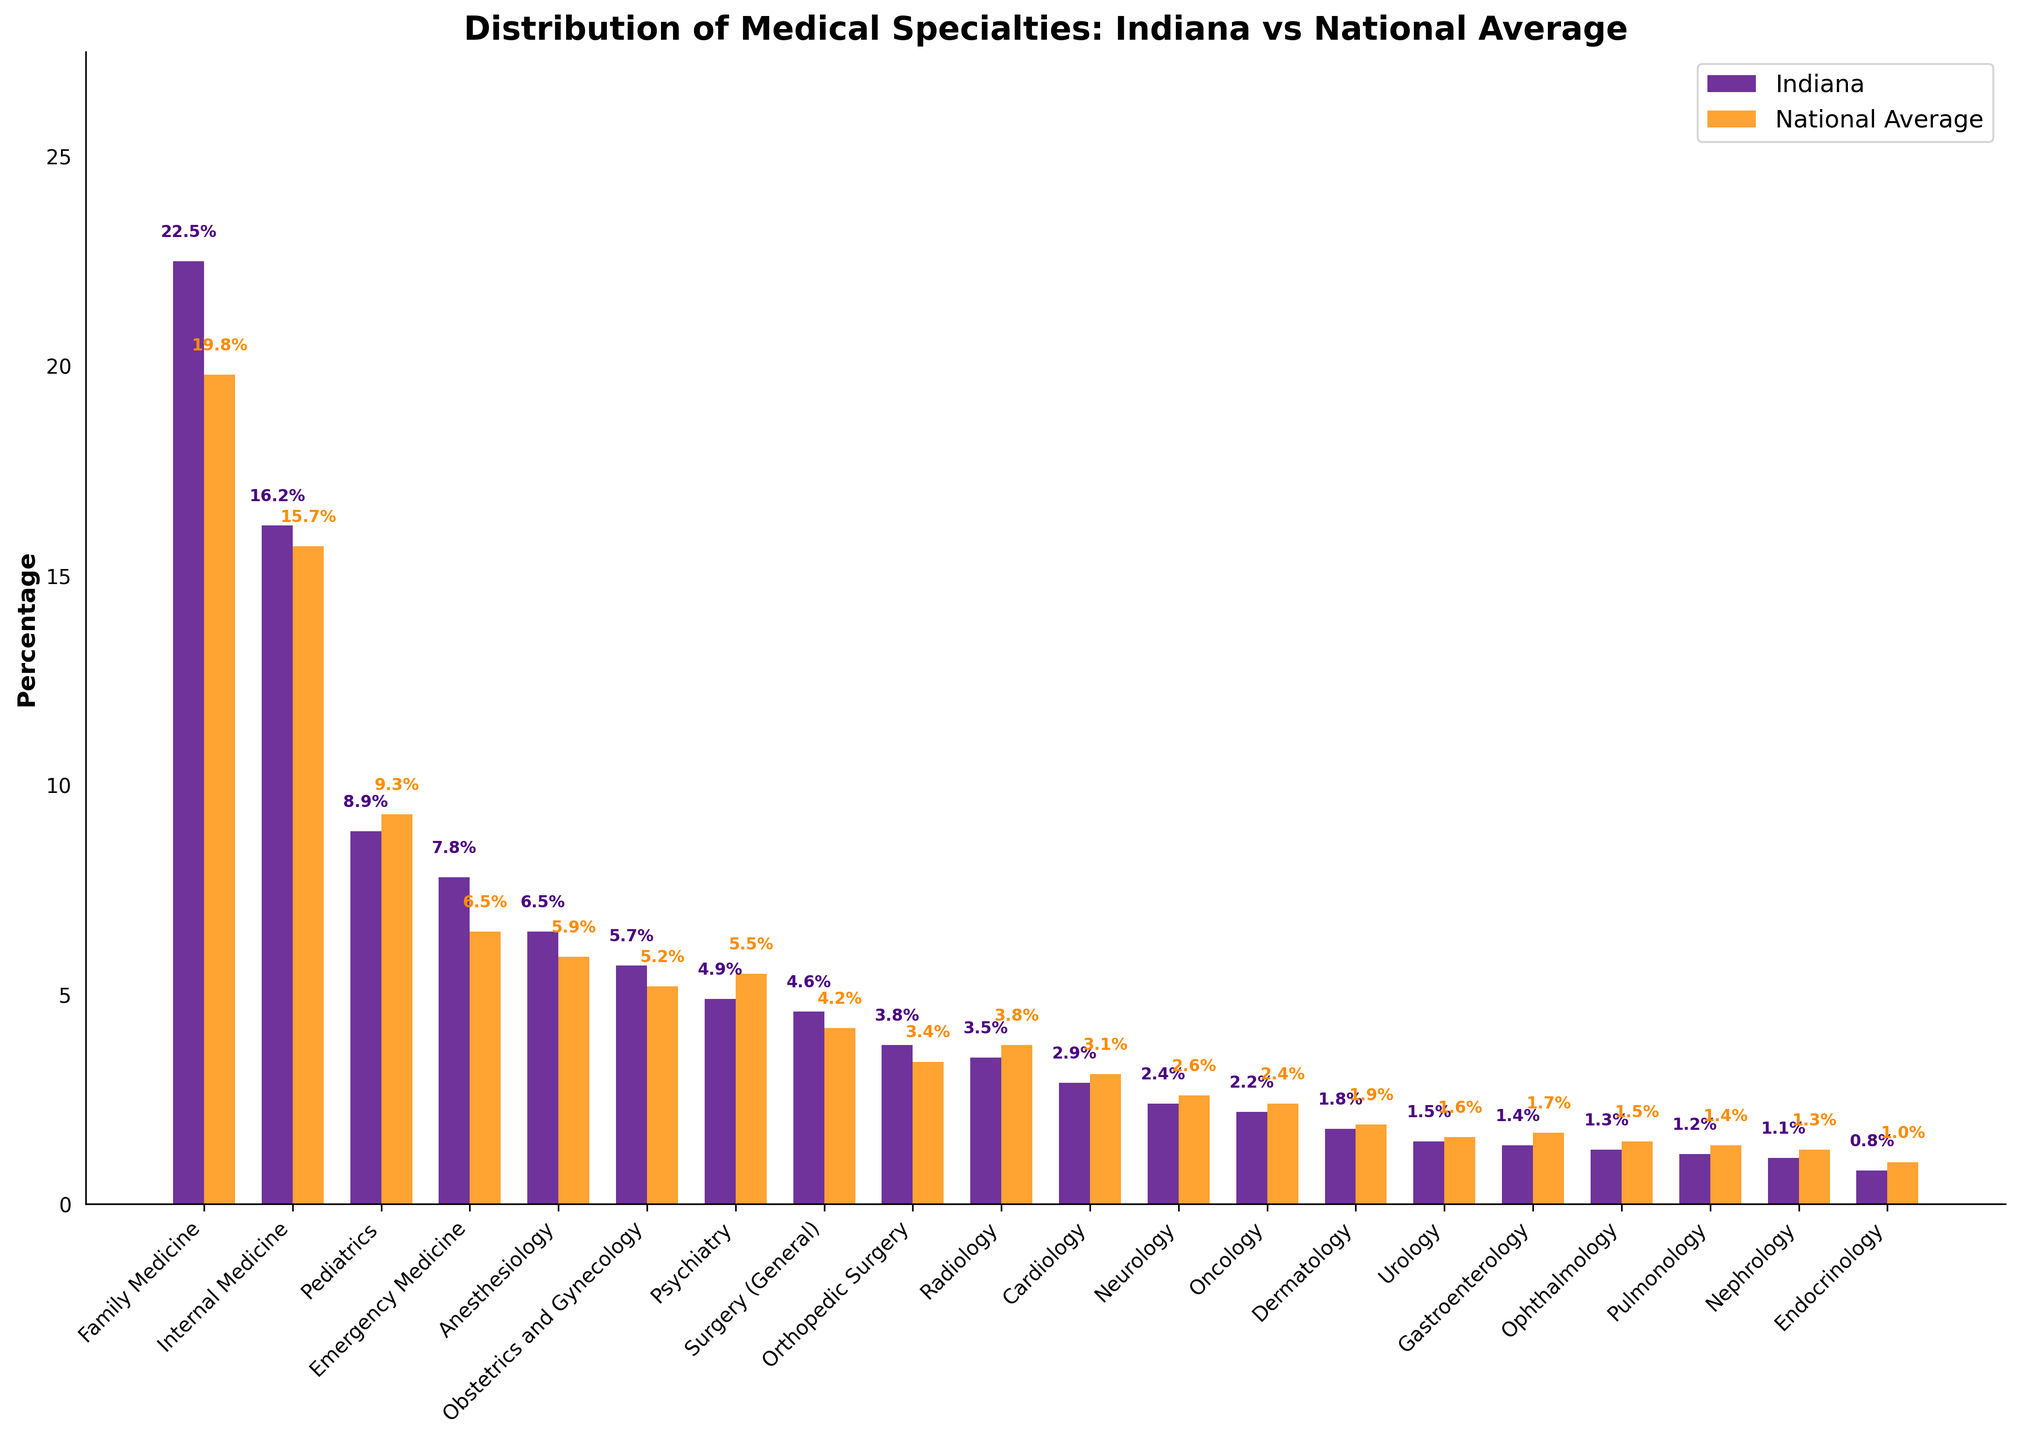Which specialty has the highest percentage in Indiana? Look for the tallest bar in the "Indiana" section of the chart. Family Medicine has the highest percentage at 22.5%.
Answer: Family Medicine Which specialty has a higher percentage in Indiana compared to the national average? Compare the height of the bars for each specialty. Indiana has higher percentages in Family Medicine, Internal Medicine, Emergency Medicine, and several others.
Answer: Family Medicine, Internal Medicine, Emergency Medicine, Anesthesiology, Obstetrics and Gynecology, Surgery (General), Orthopedic Surgery Which specialties have a lower percentage in Indiana compared to the national average? Compare the bars’ heights. Psychiarty, Cardiology, Neurology, Oncology, Dermatology, Urology, Gastroenterology, Ophthalmology, Pulmonology, Nephrology, Endocrinology have lower percentages in Indiana.
Answer: Psychiatry, Radiology, Cardiology, Neurology, Oncology, Dermatology, Urology, Gastroenterology, Ophthalmology, Pulmonology, Nephrology, Endocrinology What is the difference in percentage between Family Medicine and Internal Medicine in Indiana? Subtract the percentage of Internal Medicine (16.2%) from Family Medicine (22.5%).
Answer: 6.3% Which specialty shows the largest positive difference when comparing Indiana to the national average? Examine the differences between Indiana percentages and national averages. Family Medicine has the largest positive difference (22.5% - 19.8% = 2.7%).
Answer: Family Medicine How many specialties in Indiana have percentages higher than 5%? Count the number of bars in the "Indiana" section that exceed the 5% mark. Family Medicine, Internal Medicine, Pediatrics, Emergency Medicine, Anesthesiology, and Obstetrics and Gynecology exceed 5%.
Answer: 6 Which specialties are almost equal in percentage for both Indiana and the national average? Compare the pairs of bars and look for those with minimal differences. Oncology (2.2% in Indiana and 2.4% nationally) and Dermatology (1.8% in Indiana and 1.9% nationally) are close.
Answer: Oncology, Dermatology What is the average percentage of Gastroenterology, Ophthalmology, and Pulmonology in Indiana? Add the percentages of Gastroenterology (1.4%), Ophthalmology (1.3%), and Pulmonology (1.2%), then divide by 3: (1.4% + 1.3% + 1.2%) / 3.
Answer: 1.3% How do the percentages of Surgery (General) and Orthopedic Surgery in Indiana compare to the national average? Subtract the national averages from Indiana percentages: Surgery (General) 4.6% - 4.2% = 0.4%, Orthopedic Surgery 3.8% - 3.4% = 0.4%. Both are higher by 0.4%.
Answer: Both are higher by 0.4% What is the combined percentage of the top three specialties in Indiana? Add the percentages of Family Medicine (22.5%), Internal Medicine (16.2%), and Pediatrics (8.9%).
Answer: 47.6% 